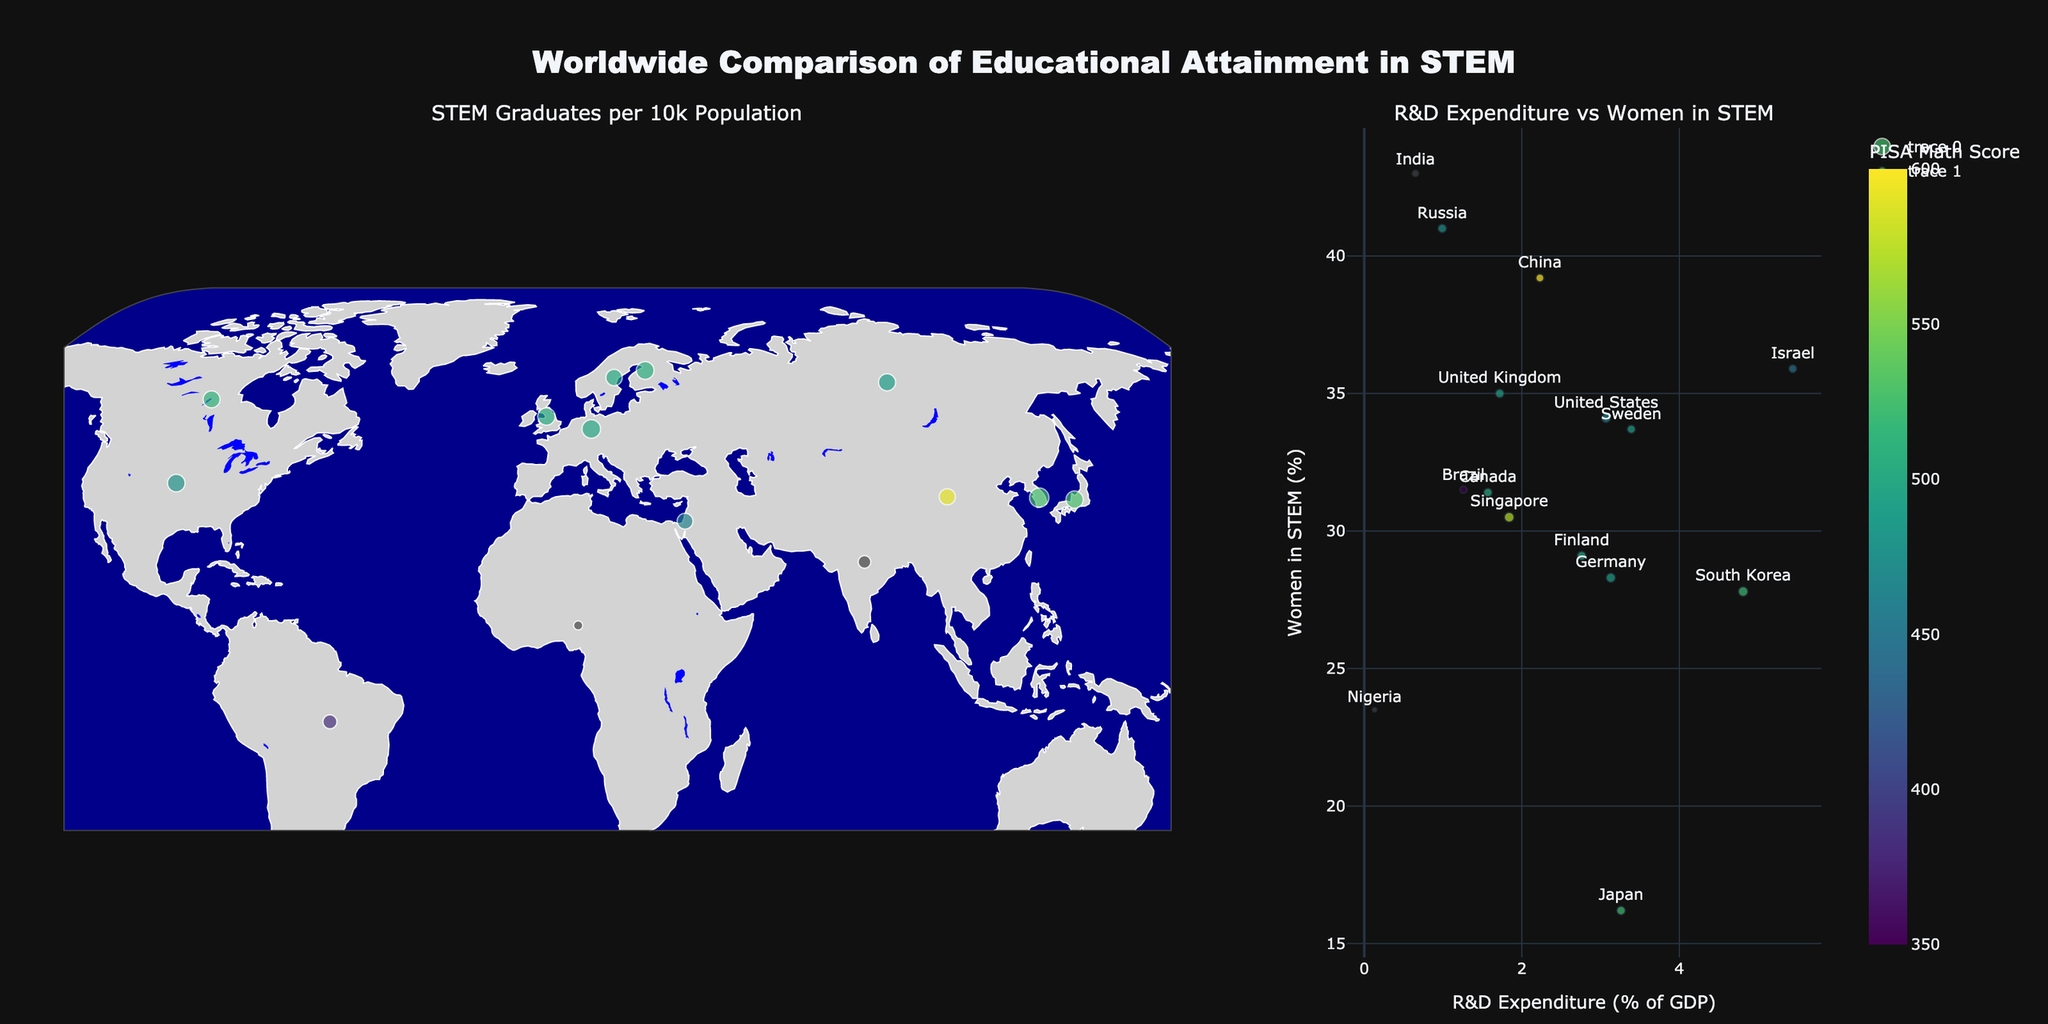What's the title of the figure? The title is located at the top of the figure. It reads "Worldwide Comparison of Educational Attainment in STEM".
Answer: Worldwide Comparison of Educational Attainment in STEM How many countries have their Women in STEM percentage above 35%? The right side scatter plot shows the Women in STEM percentage on the vertical axis. By checking the countries listed and their points, you can count the number of countries whose marker points are above 35% on this axis.
Answer: 6 Which country spends the highest percentage of GDP on R&D? Look at the scatter plot on the right side, focusing on the horizontal axis labeled "R&D Expenditure (% of GDP)". Identify the country with the highest value.
Answer: Israel What is the average PISA Math Score for South Korea and Japan? Refer to the geographic scatter plot on the left and find the PISA Math Scores for South Korea (526) and Japan (527). Then calculate the average: (526 + 527) / 2 = 526.5.
Answer: 526.5 Which countries are missing PISA Math Scores on the map, and how can you tell? Use the geographic scatter plot on the left side and identify the countries without colorcoded PISA Math Scores (these will have markers not colored by the 'Viridis' scale). The countries lacking this score are labeled in the data as N/A.
Answer: India and Nigeria Which country has the highest percentage of Women in STEM, and what's its R&D expenditure? Look at the scatter plot on the right and identify the country with the highest point on the vertical axis. This country is India with Women in STEM percentage being 43%. Its horizontal position shows its R&D as 0.65%.
Answer: India, 0.65% How does the number of STEM Graduates per 10k population relate to PISA Math Score for China and Singapore? Refer to the scatter points for China and Singapore. China has 18.4 STEM graduates with a PISA score of 591, while Singapore has 34.7 STEM graduates with a score of 569. This shows that even though Singapore has a higher number of STEM graduates per 10k population, China's PISA Math Score is higher.
Answer: China has fewer STEM graduates but a higher PISA score than Singapore Is there a general trend between R&D expenditure and Women in STEM percentage? Examine the scatter plot on the right. Observe if higher R&D expenditures correlate with higher or lower Women in STEM percentages. The scatter plot doesn't show a consistent trend suggesting any strong correlation between R&D expenditure and Women in STEM percentage.
Answer: No clear trend Which country has the largest marker size on the geographic plot, and what does it represent? From the map on the left, the largest marker size indicates the country with the highest log-transformed STEM graduates per 10k population. The color scale also helps to affirm which is the largest. That country is Singapore.
Answer: Singapore 